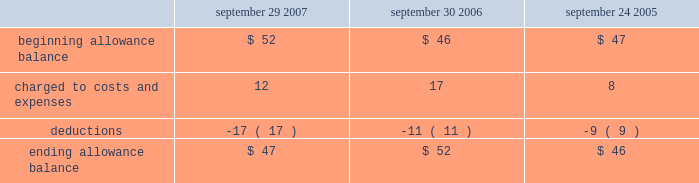Notes to consolidated financial statements ( continued ) note 2 2014financial instruments ( continued ) covered by collateral , third-party flooring arrangements , or credit insurance are outstanding with the company 2019s distribution and retail channel partners .
One customer accounted for approximately 11% ( 11 % ) of trade receivables as of september 29 , 2007 , while no customers accounted for more than 10% ( 10 % ) of trade receivables as of september 30 , 2006 .
The table summarizes the activity in the allowance for doubtful accounts ( in millions ) : september 29 , september 30 , september 24 , 2007 2006 2005 .
Vendor non-trade receivables the company has non-trade receivables from certain of its manufacturing vendors resulting from the sale of raw material components to these manufacturing vendors who manufacture sub-assemblies or assemble final products for the company .
The company purchases these raw material components directly from suppliers .
These non-trade receivables , which are included in the consolidated balance sheets in other current assets , totaled $ 2.4 billion and $ 1.6 billion as of september 29 , 2007 and september 30 , 2006 , respectively .
The company does not reflect the sale of these components in net sales and does not recognize any profits on these sales until the products are sold through to the end customer at which time the profit is recognized as a reduction of cost of sales .
Derivative financial instruments the company uses derivatives to partially offset its business exposure to foreign exchange risk .
Foreign currency forward and option contracts are used to offset the foreign exchange risk on certain existing assets and liabilities and to hedge the foreign exchange risk on expected future cash flows on certain forecasted revenue and cost of sales .
The company 2019s accounting policies for these instruments are based on whether the instruments are designated as hedge or non-hedge instruments .
The company records all derivatives on the balance sheet at fair value. .
What was the change in non-trade receivables , included in other current assets , between september 29 , 2007 and september 30 , 2006 , in billions? 
Computations: (2.4 - 1.6)
Answer: 0.8. 